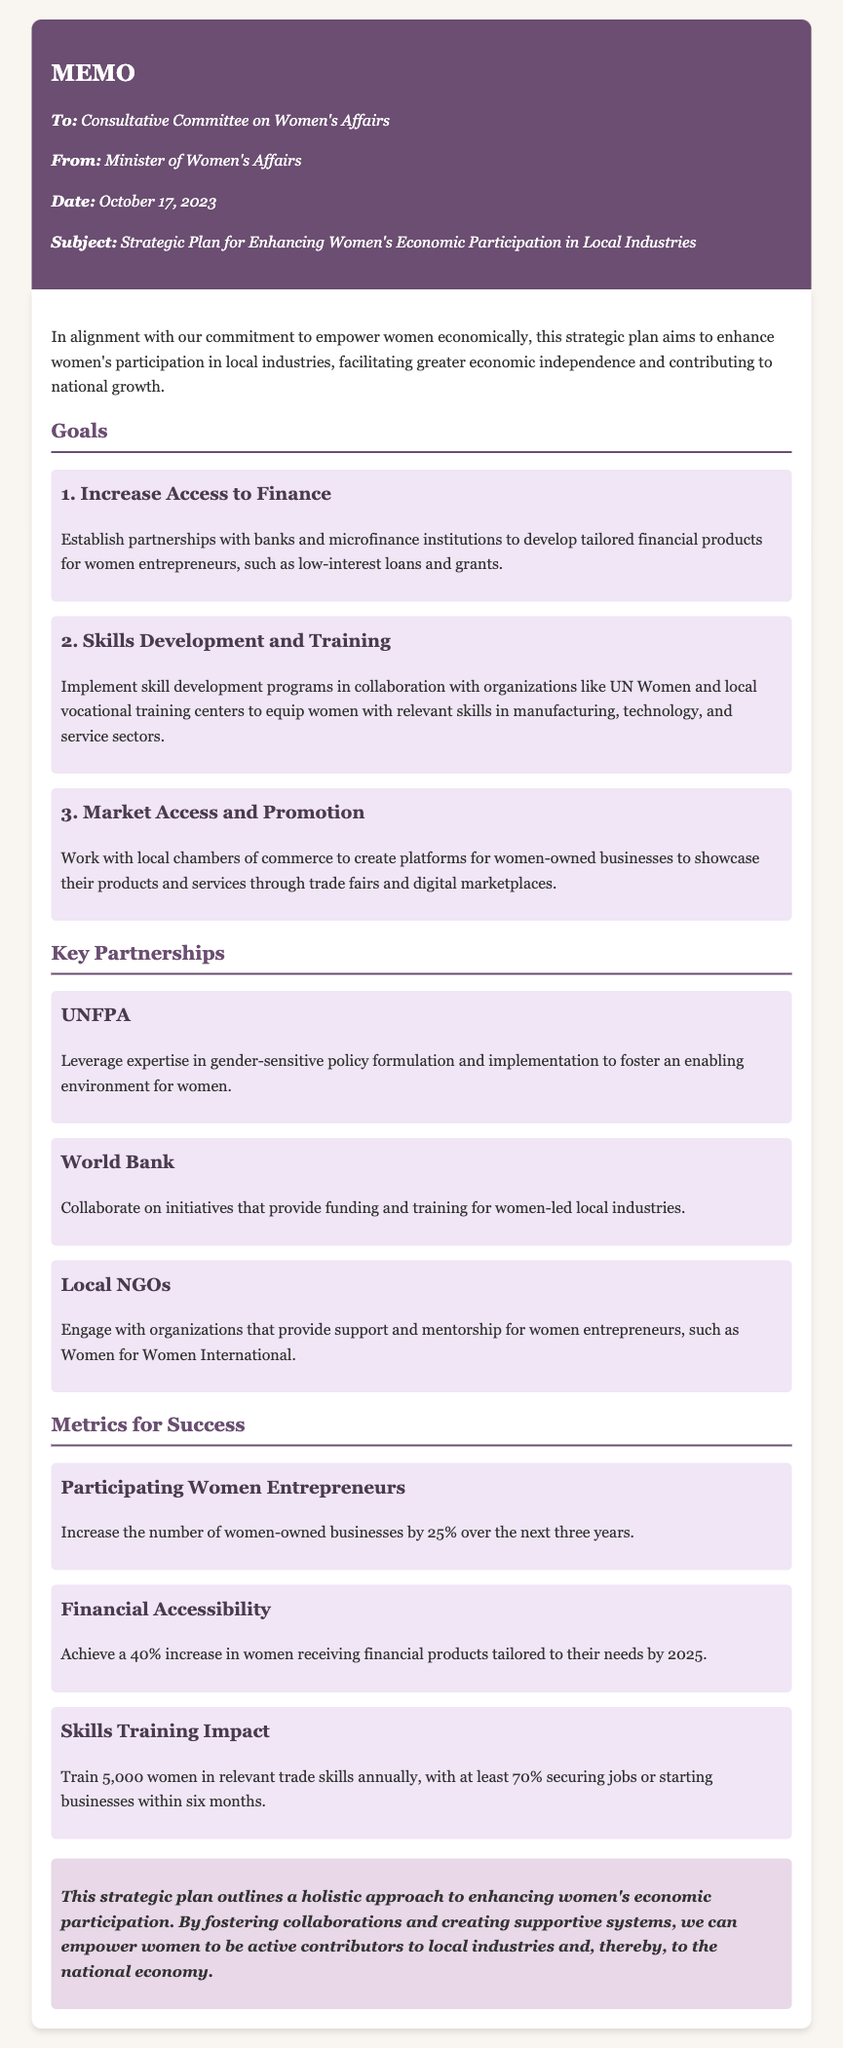What is the date of the memo? The date of the memo is explicitly stated in the document.
Answer: October 17, 2023 How many goals are outlined in the strategic plan? The document lists the goals section, where the total number of goals can be counted.
Answer: 3 What is the first goal mentioned in the memo? The first goal is clearly stated under the goals section.
Answer: Increase Access to Finance Who is one of the key partners listed in the memo? The partnerships section contains the names of organizations involved, which can be retrieved easily.
Answer: UNFPA What is the target percentage increase for women-owned businesses? The metrics section outlines specific targets set for the initiative.
Answer: 25% How many women are aimed to be trained annually in relevant trade skills? The document provides a target number for the skills training metric.
Answer: 5,000 What is the metric for financial accessibility increase? The metrics for success include specific percentage increases that are outlined in the document.
Answer: 40% What is the conclusion of the memo emphasizing? The conclusion summarizes the overall aim of the strategic plan, providing insight into its ultimate goal.
Answer: Economic participation What is one expected outcome for women who receive training? The metrics section specifies outcomes related to job placement or business initiation after training.
Answer: 70% 